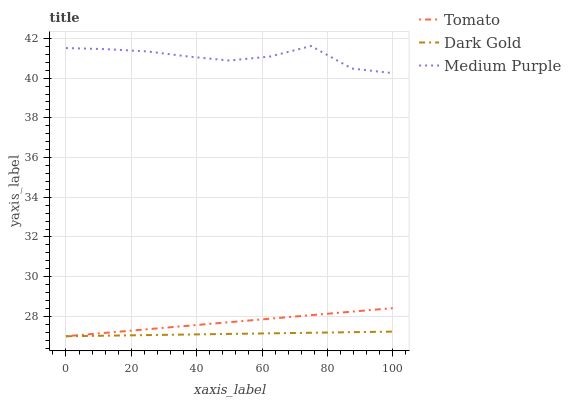Does Dark Gold have the minimum area under the curve?
Answer yes or no. Yes. Does Medium Purple have the maximum area under the curve?
Answer yes or no. Yes. Does Medium Purple have the minimum area under the curve?
Answer yes or no. No. Does Dark Gold have the maximum area under the curve?
Answer yes or no. No. Is Dark Gold the smoothest?
Answer yes or no. Yes. Is Medium Purple the roughest?
Answer yes or no. Yes. Is Medium Purple the smoothest?
Answer yes or no. No. Is Dark Gold the roughest?
Answer yes or no. No. Does Tomato have the lowest value?
Answer yes or no. Yes. Does Medium Purple have the lowest value?
Answer yes or no. No. Does Medium Purple have the highest value?
Answer yes or no. Yes. Does Dark Gold have the highest value?
Answer yes or no. No. Is Dark Gold less than Medium Purple?
Answer yes or no. Yes. Is Medium Purple greater than Dark Gold?
Answer yes or no. Yes. Does Dark Gold intersect Tomato?
Answer yes or no. Yes. Is Dark Gold less than Tomato?
Answer yes or no. No. Is Dark Gold greater than Tomato?
Answer yes or no. No. Does Dark Gold intersect Medium Purple?
Answer yes or no. No. 